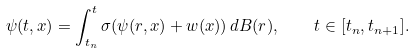Convert formula to latex. <formula><loc_0><loc_0><loc_500><loc_500>\psi ( t , x ) = \int _ { t _ { n } } ^ { t } \sigma ( \psi ( r , x ) + w ( x ) ) \, d B ( r ) , \quad t \in [ t _ { n } , t _ { n + 1 } ] .</formula> 